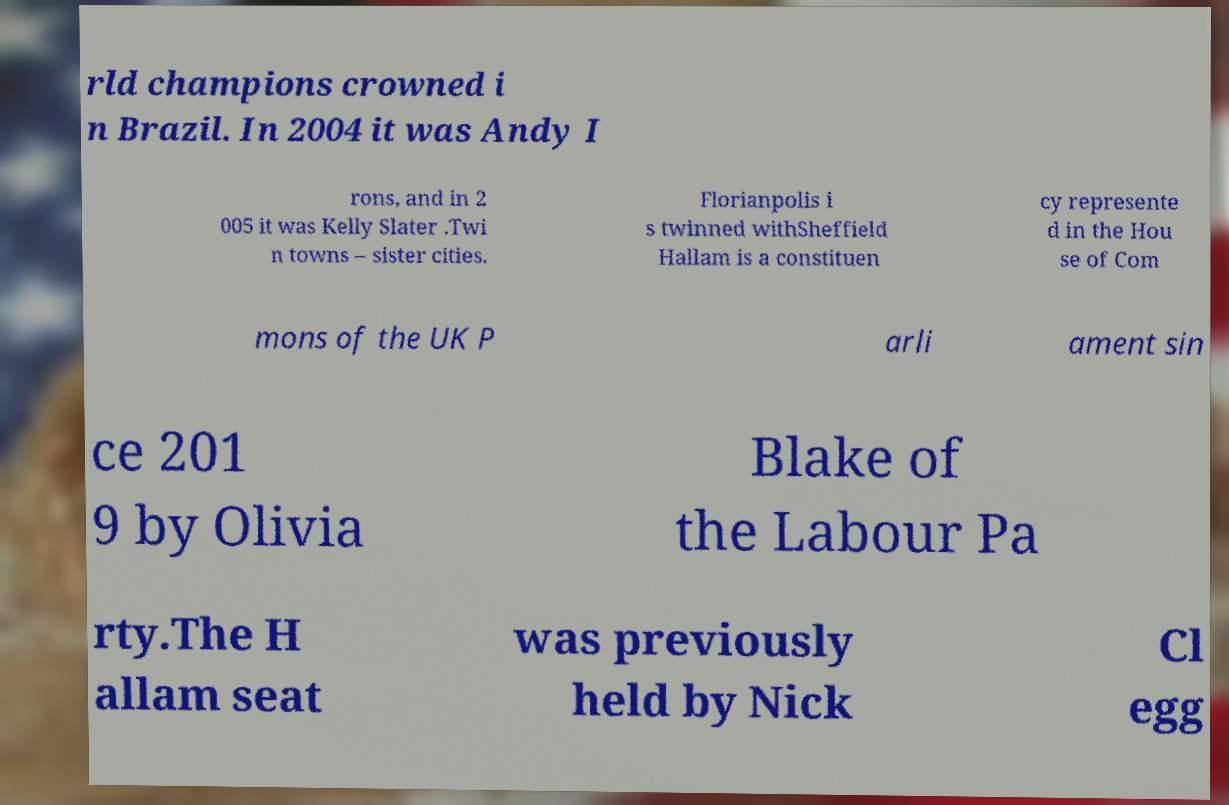Can you read and provide the text displayed in the image?This photo seems to have some interesting text. Can you extract and type it out for me? rld champions crowned i n Brazil. In 2004 it was Andy I rons, and in 2 005 it was Kelly Slater .Twi n towns – sister cities. Florianpolis i s twinned withSheffield Hallam is a constituen cy represente d in the Hou se of Com mons of the UK P arli ament sin ce 201 9 by Olivia Blake of the Labour Pa rty.The H allam seat was previously held by Nick Cl egg 